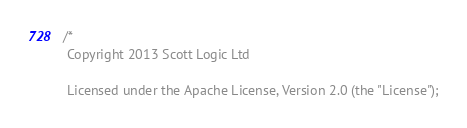Convert code to text. <code><loc_0><loc_0><loc_500><loc_500><_ObjectiveC_>/*
 Copyright 2013 Scott Logic Ltd
 
 Licensed under the Apache License, Version 2.0 (the "License");</code> 